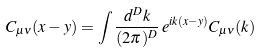<formula> <loc_0><loc_0><loc_500><loc_500>C _ { \mu \nu } ( x - y ) = \int \frac { d ^ { D } k } { ( 2 \pi ) ^ { D } } \, e ^ { i k ( x - y ) } C _ { \mu \nu } ( k )</formula> 